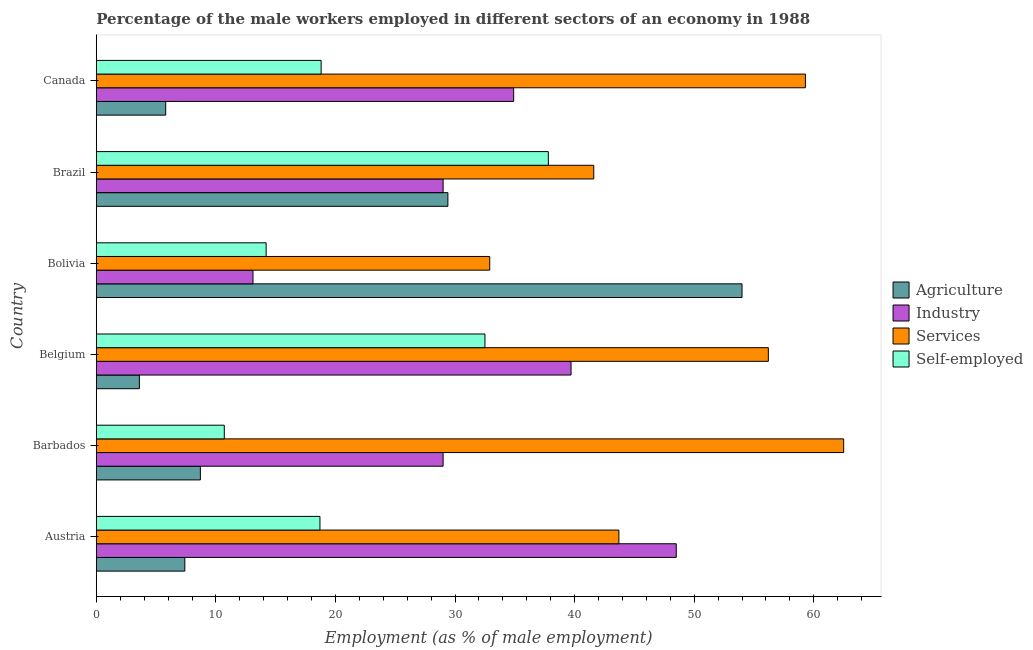How many different coloured bars are there?
Provide a short and direct response. 4. Are the number of bars on each tick of the Y-axis equal?
Your answer should be very brief. Yes. How many bars are there on the 2nd tick from the bottom?
Give a very brief answer. 4. In how many cases, is the number of bars for a given country not equal to the number of legend labels?
Make the answer very short. 0. What is the percentage of male workers in agriculture in Brazil?
Provide a succinct answer. 29.4. Across all countries, what is the maximum percentage of self employed male workers?
Offer a terse response. 37.8. Across all countries, what is the minimum percentage of male workers in industry?
Offer a terse response. 13.1. What is the total percentage of male workers in industry in the graph?
Provide a short and direct response. 194.2. What is the difference between the percentage of male workers in agriculture in Austria and the percentage of male workers in services in Belgium?
Your response must be concise. -48.8. What is the average percentage of male workers in services per country?
Your response must be concise. 49.37. What is the difference between the percentage of self employed male workers and percentage of male workers in industry in Canada?
Your answer should be compact. -16.1. What is the ratio of the percentage of self employed male workers in Belgium to that in Brazil?
Keep it short and to the point. 0.86. Is the percentage of male workers in services in Belgium less than that in Canada?
Your response must be concise. Yes. What is the difference between the highest and the second highest percentage of male workers in services?
Ensure brevity in your answer.  3.2. What is the difference between the highest and the lowest percentage of male workers in services?
Provide a succinct answer. 29.6. In how many countries, is the percentage of male workers in industry greater than the average percentage of male workers in industry taken over all countries?
Keep it short and to the point. 3. Is the sum of the percentage of male workers in industry in Austria and Belgium greater than the maximum percentage of male workers in agriculture across all countries?
Offer a very short reply. Yes. What does the 3rd bar from the top in Belgium represents?
Offer a very short reply. Industry. What does the 3rd bar from the bottom in Austria represents?
Ensure brevity in your answer.  Services. Is it the case that in every country, the sum of the percentage of male workers in agriculture and percentage of male workers in industry is greater than the percentage of male workers in services?
Keep it short and to the point. No. How many bars are there?
Your response must be concise. 24. What is the difference between two consecutive major ticks on the X-axis?
Make the answer very short. 10. Are the values on the major ticks of X-axis written in scientific E-notation?
Provide a succinct answer. No. What is the title of the graph?
Your response must be concise. Percentage of the male workers employed in different sectors of an economy in 1988. Does "Financial sector" appear as one of the legend labels in the graph?
Your answer should be compact. No. What is the label or title of the X-axis?
Offer a very short reply. Employment (as % of male employment). What is the Employment (as % of male employment) of Agriculture in Austria?
Keep it short and to the point. 7.4. What is the Employment (as % of male employment) in Industry in Austria?
Your response must be concise. 48.5. What is the Employment (as % of male employment) in Services in Austria?
Offer a very short reply. 43.7. What is the Employment (as % of male employment) of Self-employed in Austria?
Make the answer very short. 18.7. What is the Employment (as % of male employment) in Agriculture in Barbados?
Your response must be concise. 8.7. What is the Employment (as % of male employment) of Services in Barbados?
Give a very brief answer. 62.5. What is the Employment (as % of male employment) of Self-employed in Barbados?
Your response must be concise. 10.7. What is the Employment (as % of male employment) in Agriculture in Belgium?
Your response must be concise. 3.6. What is the Employment (as % of male employment) in Industry in Belgium?
Offer a very short reply. 39.7. What is the Employment (as % of male employment) of Services in Belgium?
Offer a very short reply. 56.2. What is the Employment (as % of male employment) of Self-employed in Belgium?
Offer a very short reply. 32.5. What is the Employment (as % of male employment) in Industry in Bolivia?
Provide a short and direct response. 13.1. What is the Employment (as % of male employment) in Services in Bolivia?
Offer a terse response. 32.9. What is the Employment (as % of male employment) in Self-employed in Bolivia?
Give a very brief answer. 14.2. What is the Employment (as % of male employment) of Agriculture in Brazil?
Your answer should be very brief. 29.4. What is the Employment (as % of male employment) of Services in Brazil?
Ensure brevity in your answer.  41.6. What is the Employment (as % of male employment) in Self-employed in Brazil?
Your answer should be compact. 37.8. What is the Employment (as % of male employment) of Agriculture in Canada?
Your answer should be compact. 5.8. What is the Employment (as % of male employment) of Industry in Canada?
Your response must be concise. 34.9. What is the Employment (as % of male employment) in Services in Canada?
Offer a very short reply. 59.3. What is the Employment (as % of male employment) of Self-employed in Canada?
Offer a terse response. 18.8. Across all countries, what is the maximum Employment (as % of male employment) of Industry?
Ensure brevity in your answer.  48.5. Across all countries, what is the maximum Employment (as % of male employment) of Services?
Your response must be concise. 62.5. Across all countries, what is the maximum Employment (as % of male employment) in Self-employed?
Give a very brief answer. 37.8. Across all countries, what is the minimum Employment (as % of male employment) in Agriculture?
Offer a very short reply. 3.6. Across all countries, what is the minimum Employment (as % of male employment) of Industry?
Provide a short and direct response. 13.1. Across all countries, what is the minimum Employment (as % of male employment) of Services?
Provide a succinct answer. 32.9. Across all countries, what is the minimum Employment (as % of male employment) of Self-employed?
Keep it short and to the point. 10.7. What is the total Employment (as % of male employment) of Agriculture in the graph?
Provide a succinct answer. 108.9. What is the total Employment (as % of male employment) in Industry in the graph?
Offer a terse response. 194.2. What is the total Employment (as % of male employment) of Services in the graph?
Your answer should be very brief. 296.2. What is the total Employment (as % of male employment) in Self-employed in the graph?
Ensure brevity in your answer.  132.7. What is the difference between the Employment (as % of male employment) of Industry in Austria and that in Barbados?
Keep it short and to the point. 19.5. What is the difference between the Employment (as % of male employment) of Services in Austria and that in Barbados?
Ensure brevity in your answer.  -18.8. What is the difference between the Employment (as % of male employment) of Agriculture in Austria and that in Belgium?
Ensure brevity in your answer.  3.8. What is the difference between the Employment (as % of male employment) in Industry in Austria and that in Belgium?
Your answer should be very brief. 8.8. What is the difference between the Employment (as % of male employment) of Services in Austria and that in Belgium?
Offer a very short reply. -12.5. What is the difference between the Employment (as % of male employment) in Agriculture in Austria and that in Bolivia?
Your response must be concise. -46.6. What is the difference between the Employment (as % of male employment) in Industry in Austria and that in Bolivia?
Offer a very short reply. 35.4. What is the difference between the Employment (as % of male employment) in Services in Austria and that in Brazil?
Provide a succinct answer. 2.1. What is the difference between the Employment (as % of male employment) in Self-employed in Austria and that in Brazil?
Provide a succinct answer. -19.1. What is the difference between the Employment (as % of male employment) in Industry in Austria and that in Canada?
Make the answer very short. 13.6. What is the difference between the Employment (as % of male employment) of Services in Austria and that in Canada?
Keep it short and to the point. -15.6. What is the difference between the Employment (as % of male employment) in Industry in Barbados and that in Belgium?
Provide a succinct answer. -10.7. What is the difference between the Employment (as % of male employment) of Services in Barbados and that in Belgium?
Provide a short and direct response. 6.3. What is the difference between the Employment (as % of male employment) in Self-employed in Barbados and that in Belgium?
Provide a succinct answer. -21.8. What is the difference between the Employment (as % of male employment) of Agriculture in Barbados and that in Bolivia?
Your answer should be very brief. -45.3. What is the difference between the Employment (as % of male employment) in Services in Barbados and that in Bolivia?
Keep it short and to the point. 29.6. What is the difference between the Employment (as % of male employment) of Self-employed in Barbados and that in Bolivia?
Your answer should be compact. -3.5. What is the difference between the Employment (as % of male employment) in Agriculture in Barbados and that in Brazil?
Offer a very short reply. -20.7. What is the difference between the Employment (as % of male employment) in Services in Barbados and that in Brazil?
Your answer should be compact. 20.9. What is the difference between the Employment (as % of male employment) of Self-employed in Barbados and that in Brazil?
Keep it short and to the point. -27.1. What is the difference between the Employment (as % of male employment) in Services in Barbados and that in Canada?
Ensure brevity in your answer.  3.2. What is the difference between the Employment (as % of male employment) of Agriculture in Belgium and that in Bolivia?
Your answer should be compact. -50.4. What is the difference between the Employment (as % of male employment) in Industry in Belgium and that in Bolivia?
Your answer should be compact. 26.6. What is the difference between the Employment (as % of male employment) of Services in Belgium and that in Bolivia?
Offer a terse response. 23.3. What is the difference between the Employment (as % of male employment) in Agriculture in Belgium and that in Brazil?
Make the answer very short. -25.8. What is the difference between the Employment (as % of male employment) of Industry in Belgium and that in Brazil?
Give a very brief answer. 10.7. What is the difference between the Employment (as % of male employment) in Self-employed in Belgium and that in Brazil?
Make the answer very short. -5.3. What is the difference between the Employment (as % of male employment) of Agriculture in Belgium and that in Canada?
Your answer should be very brief. -2.2. What is the difference between the Employment (as % of male employment) of Industry in Belgium and that in Canada?
Make the answer very short. 4.8. What is the difference between the Employment (as % of male employment) of Self-employed in Belgium and that in Canada?
Your answer should be very brief. 13.7. What is the difference between the Employment (as % of male employment) of Agriculture in Bolivia and that in Brazil?
Make the answer very short. 24.6. What is the difference between the Employment (as % of male employment) in Industry in Bolivia and that in Brazil?
Your answer should be compact. -15.9. What is the difference between the Employment (as % of male employment) of Services in Bolivia and that in Brazil?
Your answer should be compact. -8.7. What is the difference between the Employment (as % of male employment) of Self-employed in Bolivia and that in Brazil?
Keep it short and to the point. -23.6. What is the difference between the Employment (as % of male employment) in Agriculture in Bolivia and that in Canada?
Make the answer very short. 48.2. What is the difference between the Employment (as % of male employment) in Industry in Bolivia and that in Canada?
Offer a very short reply. -21.8. What is the difference between the Employment (as % of male employment) of Services in Bolivia and that in Canada?
Offer a terse response. -26.4. What is the difference between the Employment (as % of male employment) in Self-employed in Bolivia and that in Canada?
Ensure brevity in your answer.  -4.6. What is the difference between the Employment (as % of male employment) in Agriculture in Brazil and that in Canada?
Your answer should be compact. 23.6. What is the difference between the Employment (as % of male employment) of Industry in Brazil and that in Canada?
Keep it short and to the point. -5.9. What is the difference between the Employment (as % of male employment) in Services in Brazil and that in Canada?
Keep it short and to the point. -17.7. What is the difference between the Employment (as % of male employment) of Self-employed in Brazil and that in Canada?
Your answer should be compact. 19. What is the difference between the Employment (as % of male employment) of Agriculture in Austria and the Employment (as % of male employment) of Industry in Barbados?
Your response must be concise. -21.6. What is the difference between the Employment (as % of male employment) of Agriculture in Austria and the Employment (as % of male employment) of Services in Barbados?
Offer a terse response. -55.1. What is the difference between the Employment (as % of male employment) in Agriculture in Austria and the Employment (as % of male employment) in Self-employed in Barbados?
Offer a terse response. -3.3. What is the difference between the Employment (as % of male employment) of Industry in Austria and the Employment (as % of male employment) of Services in Barbados?
Your response must be concise. -14. What is the difference between the Employment (as % of male employment) of Industry in Austria and the Employment (as % of male employment) of Self-employed in Barbados?
Provide a succinct answer. 37.8. What is the difference between the Employment (as % of male employment) in Services in Austria and the Employment (as % of male employment) in Self-employed in Barbados?
Offer a terse response. 33. What is the difference between the Employment (as % of male employment) of Agriculture in Austria and the Employment (as % of male employment) of Industry in Belgium?
Your response must be concise. -32.3. What is the difference between the Employment (as % of male employment) of Agriculture in Austria and the Employment (as % of male employment) of Services in Belgium?
Provide a short and direct response. -48.8. What is the difference between the Employment (as % of male employment) of Agriculture in Austria and the Employment (as % of male employment) of Self-employed in Belgium?
Your answer should be compact. -25.1. What is the difference between the Employment (as % of male employment) of Industry in Austria and the Employment (as % of male employment) of Self-employed in Belgium?
Offer a very short reply. 16. What is the difference between the Employment (as % of male employment) of Agriculture in Austria and the Employment (as % of male employment) of Services in Bolivia?
Your answer should be very brief. -25.5. What is the difference between the Employment (as % of male employment) in Industry in Austria and the Employment (as % of male employment) in Self-employed in Bolivia?
Provide a short and direct response. 34.3. What is the difference between the Employment (as % of male employment) of Services in Austria and the Employment (as % of male employment) of Self-employed in Bolivia?
Your response must be concise. 29.5. What is the difference between the Employment (as % of male employment) in Agriculture in Austria and the Employment (as % of male employment) in Industry in Brazil?
Ensure brevity in your answer.  -21.6. What is the difference between the Employment (as % of male employment) of Agriculture in Austria and the Employment (as % of male employment) of Services in Brazil?
Provide a short and direct response. -34.2. What is the difference between the Employment (as % of male employment) in Agriculture in Austria and the Employment (as % of male employment) in Self-employed in Brazil?
Give a very brief answer. -30.4. What is the difference between the Employment (as % of male employment) of Services in Austria and the Employment (as % of male employment) of Self-employed in Brazil?
Provide a succinct answer. 5.9. What is the difference between the Employment (as % of male employment) in Agriculture in Austria and the Employment (as % of male employment) in Industry in Canada?
Offer a terse response. -27.5. What is the difference between the Employment (as % of male employment) in Agriculture in Austria and the Employment (as % of male employment) in Services in Canada?
Provide a succinct answer. -51.9. What is the difference between the Employment (as % of male employment) of Industry in Austria and the Employment (as % of male employment) of Self-employed in Canada?
Make the answer very short. 29.7. What is the difference between the Employment (as % of male employment) of Services in Austria and the Employment (as % of male employment) of Self-employed in Canada?
Offer a terse response. 24.9. What is the difference between the Employment (as % of male employment) of Agriculture in Barbados and the Employment (as % of male employment) of Industry in Belgium?
Keep it short and to the point. -31. What is the difference between the Employment (as % of male employment) in Agriculture in Barbados and the Employment (as % of male employment) in Services in Belgium?
Ensure brevity in your answer.  -47.5. What is the difference between the Employment (as % of male employment) in Agriculture in Barbados and the Employment (as % of male employment) in Self-employed in Belgium?
Your answer should be compact. -23.8. What is the difference between the Employment (as % of male employment) in Industry in Barbados and the Employment (as % of male employment) in Services in Belgium?
Provide a succinct answer. -27.2. What is the difference between the Employment (as % of male employment) of Industry in Barbados and the Employment (as % of male employment) of Self-employed in Belgium?
Your answer should be very brief. -3.5. What is the difference between the Employment (as % of male employment) in Agriculture in Barbados and the Employment (as % of male employment) in Services in Bolivia?
Offer a terse response. -24.2. What is the difference between the Employment (as % of male employment) of Industry in Barbados and the Employment (as % of male employment) of Services in Bolivia?
Offer a very short reply. -3.9. What is the difference between the Employment (as % of male employment) of Industry in Barbados and the Employment (as % of male employment) of Self-employed in Bolivia?
Offer a very short reply. 14.8. What is the difference between the Employment (as % of male employment) of Services in Barbados and the Employment (as % of male employment) of Self-employed in Bolivia?
Give a very brief answer. 48.3. What is the difference between the Employment (as % of male employment) of Agriculture in Barbados and the Employment (as % of male employment) of Industry in Brazil?
Your answer should be compact. -20.3. What is the difference between the Employment (as % of male employment) of Agriculture in Barbados and the Employment (as % of male employment) of Services in Brazil?
Offer a very short reply. -32.9. What is the difference between the Employment (as % of male employment) in Agriculture in Barbados and the Employment (as % of male employment) in Self-employed in Brazil?
Offer a very short reply. -29.1. What is the difference between the Employment (as % of male employment) of Industry in Barbados and the Employment (as % of male employment) of Services in Brazil?
Provide a succinct answer. -12.6. What is the difference between the Employment (as % of male employment) of Services in Barbados and the Employment (as % of male employment) of Self-employed in Brazil?
Provide a short and direct response. 24.7. What is the difference between the Employment (as % of male employment) of Agriculture in Barbados and the Employment (as % of male employment) of Industry in Canada?
Ensure brevity in your answer.  -26.2. What is the difference between the Employment (as % of male employment) in Agriculture in Barbados and the Employment (as % of male employment) in Services in Canada?
Give a very brief answer. -50.6. What is the difference between the Employment (as % of male employment) in Industry in Barbados and the Employment (as % of male employment) in Services in Canada?
Your answer should be very brief. -30.3. What is the difference between the Employment (as % of male employment) in Services in Barbados and the Employment (as % of male employment) in Self-employed in Canada?
Your answer should be compact. 43.7. What is the difference between the Employment (as % of male employment) of Agriculture in Belgium and the Employment (as % of male employment) of Industry in Bolivia?
Your answer should be very brief. -9.5. What is the difference between the Employment (as % of male employment) in Agriculture in Belgium and the Employment (as % of male employment) in Services in Bolivia?
Your answer should be very brief. -29.3. What is the difference between the Employment (as % of male employment) of Agriculture in Belgium and the Employment (as % of male employment) of Self-employed in Bolivia?
Provide a succinct answer. -10.6. What is the difference between the Employment (as % of male employment) in Industry in Belgium and the Employment (as % of male employment) in Services in Bolivia?
Provide a short and direct response. 6.8. What is the difference between the Employment (as % of male employment) of Industry in Belgium and the Employment (as % of male employment) of Self-employed in Bolivia?
Your answer should be very brief. 25.5. What is the difference between the Employment (as % of male employment) in Agriculture in Belgium and the Employment (as % of male employment) in Industry in Brazil?
Make the answer very short. -25.4. What is the difference between the Employment (as % of male employment) of Agriculture in Belgium and the Employment (as % of male employment) of Services in Brazil?
Your answer should be very brief. -38. What is the difference between the Employment (as % of male employment) in Agriculture in Belgium and the Employment (as % of male employment) in Self-employed in Brazil?
Keep it short and to the point. -34.2. What is the difference between the Employment (as % of male employment) in Industry in Belgium and the Employment (as % of male employment) in Services in Brazil?
Offer a very short reply. -1.9. What is the difference between the Employment (as % of male employment) in Industry in Belgium and the Employment (as % of male employment) in Self-employed in Brazil?
Your answer should be compact. 1.9. What is the difference between the Employment (as % of male employment) of Services in Belgium and the Employment (as % of male employment) of Self-employed in Brazil?
Your response must be concise. 18.4. What is the difference between the Employment (as % of male employment) in Agriculture in Belgium and the Employment (as % of male employment) in Industry in Canada?
Ensure brevity in your answer.  -31.3. What is the difference between the Employment (as % of male employment) in Agriculture in Belgium and the Employment (as % of male employment) in Services in Canada?
Offer a terse response. -55.7. What is the difference between the Employment (as % of male employment) in Agriculture in Belgium and the Employment (as % of male employment) in Self-employed in Canada?
Make the answer very short. -15.2. What is the difference between the Employment (as % of male employment) of Industry in Belgium and the Employment (as % of male employment) of Services in Canada?
Keep it short and to the point. -19.6. What is the difference between the Employment (as % of male employment) of Industry in Belgium and the Employment (as % of male employment) of Self-employed in Canada?
Offer a terse response. 20.9. What is the difference between the Employment (as % of male employment) in Services in Belgium and the Employment (as % of male employment) in Self-employed in Canada?
Offer a terse response. 37.4. What is the difference between the Employment (as % of male employment) of Agriculture in Bolivia and the Employment (as % of male employment) of Services in Brazil?
Offer a terse response. 12.4. What is the difference between the Employment (as % of male employment) in Industry in Bolivia and the Employment (as % of male employment) in Services in Brazil?
Give a very brief answer. -28.5. What is the difference between the Employment (as % of male employment) in Industry in Bolivia and the Employment (as % of male employment) in Self-employed in Brazil?
Offer a terse response. -24.7. What is the difference between the Employment (as % of male employment) in Agriculture in Bolivia and the Employment (as % of male employment) in Self-employed in Canada?
Provide a short and direct response. 35.2. What is the difference between the Employment (as % of male employment) of Industry in Bolivia and the Employment (as % of male employment) of Services in Canada?
Your response must be concise. -46.2. What is the difference between the Employment (as % of male employment) of Services in Bolivia and the Employment (as % of male employment) of Self-employed in Canada?
Give a very brief answer. 14.1. What is the difference between the Employment (as % of male employment) in Agriculture in Brazil and the Employment (as % of male employment) in Industry in Canada?
Your answer should be compact. -5.5. What is the difference between the Employment (as % of male employment) of Agriculture in Brazil and the Employment (as % of male employment) of Services in Canada?
Keep it short and to the point. -29.9. What is the difference between the Employment (as % of male employment) of Agriculture in Brazil and the Employment (as % of male employment) of Self-employed in Canada?
Give a very brief answer. 10.6. What is the difference between the Employment (as % of male employment) of Industry in Brazil and the Employment (as % of male employment) of Services in Canada?
Provide a short and direct response. -30.3. What is the difference between the Employment (as % of male employment) of Services in Brazil and the Employment (as % of male employment) of Self-employed in Canada?
Provide a short and direct response. 22.8. What is the average Employment (as % of male employment) in Agriculture per country?
Your answer should be very brief. 18.15. What is the average Employment (as % of male employment) of Industry per country?
Ensure brevity in your answer.  32.37. What is the average Employment (as % of male employment) in Services per country?
Your answer should be compact. 49.37. What is the average Employment (as % of male employment) of Self-employed per country?
Make the answer very short. 22.12. What is the difference between the Employment (as % of male employment) in Agriculture and Employment (as % of male employment) in Industry in Austria?
Keep it short and to the point. -41.1. What is the difference between the Employment (as % of male employment) of Agriculture and Employment (as % of male employment) of Services in Austria?
Give a very brief answer. -36.3. What is the difference between the Employment (as % of male employment) in Industry and Employment (as % of male employment) in Services in Austria?
Offer a terse response. 4.8. What is the difference between the Employment (as % of male employment) in Industry and Employment (as % of male employment) in Self-employed in Austria?
Make the answer very short. 29.8. What is the difference between the Employment (as % of male employment) of Services and Employment (as % of male employment) of Self-employed in Austria?
Your response must be concise. 25. What is the difference between the Employment (as % of male employment) in Agriculture and Employment (as % of male employment) in Industry in Barbados?
Your answer should be very brief. -20.3. What is the difference between the Employment (as % of male employment) in Agriculture and Employment (as % of male employment) in Services in Barbados?
Your response must be concise. -53.8. What is the difference between the Employment (as % of male employment) of Agriculture and Employment (as % of male employment) of Self-employed in Barbados?
Your answer should be very brief. -2. What is the difference between the Employment (as % of male employment) in Industry and Employment (as % of male employment) in Services in Barbados?
Make the answer very short. -33.5. What is the difference between the Employment (as % of male employment) in Services and Employment (as % of male employment) in Self-employed in Barbados?
Give a very brief answer. 51.8. What is the difference between the Employment (as % of male employment) in Agriculture and Employment (as % of male employment) in Industry in Belgium?
Ensure brevity in your answer.  -36.1. What is the difference between the Employment (as % of male employment) in Agriculture and Employment (as % of male employment) in Services in Belgium?
Your response must be concise. -52.6. What is the difference between the Employment (as % of male employment) of Agriculture and Employment (as % of male employment) of Self-employed in Belgium?
Make the answer very short. -28.9. What is the difference between the Employment (as % of male employment) in Industry and Employment (as % of male employment) in Services in Belgium?
Ensure brevity in your answer.  -16.5. What is the difference between the Employment (as % of male employment) of Services and Employment (as % of male employment) of Self-employed in Belgium?
Your response must be concise. 23.7. What is the difference between the Employment (as % of male employment) in Agriculture and Employment (as % of male employment) in Industry in Bolivia?
Your response must be concise. 40.9. What is the difference between the Employment (as % of male employment) in Agriculture and Employment (as % of male employment) in Services in Bolivia?
Give a very brief answer. 21.1. What is the difference between the Employment (as % of male employment) in Agriculture and Employment (as % of male employment) in Self-employed in Bolivia?
Offer a very short reply. 39.8. What is the difference between the Employment (as % of male employment) in Industry and Employment (as % of male employment) in Services in Bolivia?
Make the answer very short. -19.8. What is the difference between the Employment (as % of male employment) of Industry and Employment (as % of male employment) of Self-employed in Bolivia?
Make the answer very short. -1.1. What is the difference between the Employment (as % of male employment) in Agriculture and Employment (as % of male employment) in Industry in Canada?
Keep it short and to the point. -29.1. What is the difference between the Employment (as % of male employment) of Agriculture and Employment (as % of male employment) of Services in Canada?
Give a very brief answer. -53.5. What is the difference between the Employment (as % of male employment) of Industry and Employment (as % of male employment) of Services in Canada?
Ensure brevity in your answer.  -24.4. What is the difference between the Employment (as % of male employment) in Services and Employment (as % of male employment) in Self-employed in Canada?
Provide a succinct answer. 40.5. What is the ratio of the Employment (as % of male employment) in Agriculture in Austria to that in Barbados?
Offer a terse response. 0.85. What is the ratio of the Employment (as % of male employment) of Industry in Austria to that in Barbados?
Your answer should be compact. 1.67. What is the ratio of the Employment (as % of male employment) of Services in Austria to that in Barbados?
Your response must be concise. 0.7. What is the ratio of the Employment (as % of male employment) in Self-employed in Austria to that in Barbados?
Your response must be concise. 1.75. What is the ratio of the Employment (as % of male employment) of Agriculture in Austria to that in Belgium?
Your answer should be compact. 2.06. What is the ratio of the Employment (as % of male employment) of Industry in Austria to that in Belgium?
Ensure brevity in your answer.  1.22. What is the ratio of the Employment (as % of male employment) in Services in Austria to that in Belgium?
Your answer should be compact. 0.78. What is the ratio of the Employment (as % of male employment) in Self-employed in Austria to that in Belgium?
Provide a succinct answer. 0.58. What is the ratio of the Employment (as % of male employment) of Agriculture in Austria to that in Bolivia?
Your answer should be very brief. 0.14. What is the ratio of the Employment (as % of male employment) in Industry in Austria to that in Bolivia?
Offer a very short reply. 3.7. What is the ratio of the Employment (as % of male employment) of Services in Austria to that in Bolivia?
Keep it short and to the point. 1.33. What is the ratio of the Employment (as % of male employment) of Self-employed in Austria to that in Bolivia?
Keep it short and to the point. 1.32. What is the ratio of the Employment (as % of male employment) in Agriculture in Austria to that in Brazil?
Make the answer very short. 0.25. What is the ratio of the Employment (as % of male employment) in Industry in Austria to that in Brazil?
Offer a very short reply. 1.67. What is the ratio of the Employment (as % of male employment) of Services in Austria to that in Brazil?
Ensure brevity in your answer.  1.05. What is the ratio of the Employment (as % of male employment) in Self-employed in Austria to that in Brazil?
Your response must be concise. 0.49. What is the ratio of the Employment (as % of male employment) of Agriculture in Austria to that in Canada?
Give a very brief answer. 1.28. What is the ratio of the Employment (as % of male employment) of Industry in Austria to that in Canada?
Give a very brief answer. 1.39. What is the ratio of the Employment (as % of male employment) of Services in Austria to that in Canada?
Offer a very short reply. 0.74. What is the ratio of the Employment (as % of male employment) in Agriculture in Barbados to that in Belgium?
Provide a succinct answer. 2.42. What is the ratio of the Employment (as % of male employment) of Industry in Barbados to that in Belgium?
Ensure brevity in your answer.  0.73. What is the ratio of the Employment (as % of male employment) in Services in Barbados to that in Belgium?
Provide a short and direct response. 1.11. What is the ratio of the Employment (as % of male employment) in Self-employed in Barbados to that in Belgium?
Keep it short and to the point. 0.33. What is the ratio of the Employment (as % of male employment) of Agriculture in Barbados to that in Bolivia?
Your answer should be very brief. 0.16. What is the ratio of the Employment (as % of male employment) in Industry in Barbados to that in Bolivia?
Your answer should be compact. 2.21. What is the ratio of the Employment (as % of male employment) in Services in Barbados to that in Bolivia?
Your answer should be compact. 1.9. What is the ratio of the Employment (as % of male employment) of Self-employed in Barbados to that in Bolivia?
Offer a very short reply. 0.75. What is the ratio of the Employment (as % of male employment) of Agriculture in Barbados to that in Brazil?
Give a very brief answer. 0.3. What is the ratio of the Employment (as % of male employment) in Industry in Barbados to that in Brazil?
Provide a succinct answer. 1. What is the ratio of the Employment (as % of male employment) in Services in Barbados to that in Brazil?
Offer a terse response. 1.5. What is the ratio of the Employment (as % of male employment) of Self-employed in Barbados to that in Brazil?
Provide a short and direct response. 0.28. What is the ratio of the Employment (as % of male employment) of Agriculture in Barbados to that in Canada?
Give a very brief answer. 1.5. What is the ratio of the Employment (as % of male employment) in Industry in Barbados to that in Canada?
Your response must be concise. 0.83. What is the ratio of the Employment (as % of male employment) in Services in Barbados to that in Canada?
Keep it short and to the point. 1.05. What is the ratio of the Employment (as % of male employment) in Self-employed in Barbados to that in Canada?
Offer a terse response. 0.57. What is the ratio of the Employment (as % of male employment) of Agriculture in Belgium to that in Bolivia?
Your answer should be very brief. 0.07. What is the ratio of the Employment (as % of male employment) of Industry in Belgium to that in Bolivia?
Make the answer very short. 3.03. What is the ratio of the Employment (as % of male employment) of Services in Belgium to that in Bolivia?
Give a very brief answer. 1.71. What is the ratio of the Employment (as % of male employment) of Self-employed in Belgium to that in Bolivia?
Your answer should be compact. 2.29. What is the ratio of the Employment (as % of male employment) of Agriculture in Belgium to that in Brazil?
Offer a terse response. 0.12. What is the ratio of the Employment (as % of male employment) of Industry in Belgium to that in Brazil?
Make the answer very short. 1.37. What is the ratio of the Employment (as % of male employment) of Services in Belgium to that in Brazil?
Provide a short and direct response. 1.35. What is the ratio of the Employment (as % of male employment) in Self-employed in Belgium to that in Brazil?
Your answer should be very brief. 0.86. What is the ratio of the Employment (as % of male employment) of Agriculture in Belgium to that in Canada?
Offer a very short reply. 0.62. What is the ratio of the Employment (as % of male employment) in Industry in Belgium to that in Canada?
Your response must be concise. 1.14. What is the ratio of the Employment (as % of male employment) in Services in Belgium to that in Canada?
Your response must be concise. 0.95. What is the ratio of the Employment (as % of male employment) in Self-employed in Belgium to that in Canada?
Provide a short and direct response. 1.73. What is the ratio of the Employment (as % of male employment) of Agriculture in Bolivia to that in Brazil?
Offer a very short reply. 1.84. What is the ratio of the Employment (as % of male employment) of Industry in Bolivia to that in Brazil?
Offer a terse response. 0.45. What is the ratio of the Employment (as % of male employment) in Services in Bolivia to that in Brazil?
Your response must be concise. 0.79. What is the ratio of the Employment (as % of male employment) of Self-employed in Bolivia to that in Brazil?
Your answer should be compact. 0.38. What is the ratio of the Employment (as % of male employment) of Agriculture in Bolivia to that in Canada?
Your response must be concise. 9.31. What is the ratio of the Employment (as % of male employment) of Industry in Bolivia to that in Canada?
Your answer should be very brief. 0.38. What is the ratio of the Employment (as % of male employment) in Services in Bolivia to that in Canada?
Your answer should be compact. 0.55. What is the ratio of the Employment (as % of male employment) in Self-employed in Bolivia to that in Canada?
Give a very brief answer. 0.76. What is the ratio of the Employment (as % of male employment) of Agriculture in Brazil to that in Canada?
Offer a terse response. 5.07. What is the ratio of the Employment (as % of male employment) of Industry in Brazil to that in Canada?
Give a very brief answer. 0.83. What is the ratio of the Employment (as % of male employment) of Services in Brazil to that in Canada?
Offer a terse response. 0.7. What is the ratio of the Employment (as % of male employment) of Self-employed in Brazil to that in Canada?
Provide a succinct answer. 2.01. What is the difference between the highest and the second highest Employment (as % of male employment) of Agriculture?
Your response must be concise. 24.6. What is the difference between the highest and the second highest Employment (as % of male employment) of Industry?
Keep it short and to the point. 8.8. What is the difference between the highest and the second highest Employment (as % of male employment) of Self-employed?
Your answer should be compact. 5.3. What is the difference between the highest and the lowest Employment (as % of male employment) in Agriculture?
Provide a succinct answer. 50.4. What is the difference between the highest and the lowest Employment (as % of male employment) in Industry?
Ensure brevity in your answer.  35.4. What is the difference between the highest and the lowest Employment (as % of male employment) of Services?
Your answer should be very brief. 29.6. What is the difference between the highest and the lowest Employment (as % of male employment) of Self-employed?
Offer a very short reply. 27.1. 